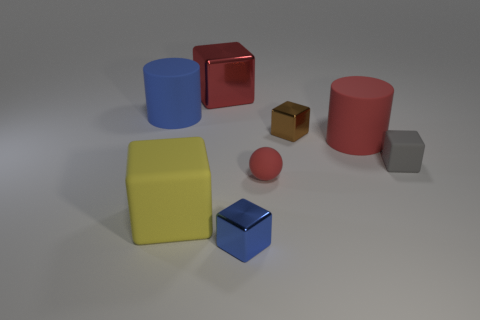Subtract all red cubes. How many cubes are left? 4 Subtract all yellow cubes. How many cubes are left? 4 Subtract all green cubes. Subtract all gray spheres. How many cubes are left? 5 Add 2 large red rubber cylinders. How many objects exist? 10 Subtract all cylinders. How many objects are left? 6 Add 1 tiny red cylinders. How many tiny red cylinders exist? 1 Subtract 0 green cylinders. How many objects are left? 8 Subtract all gray objects. Subtract all large red matte cylinders. How many objects are left? 6 Add 8 brown metallic blocks. How many brown metallic blocks are left? 9 